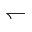Convert formula to latex. <formula><loc_0><loc_0><loc_500><loc_500>\leftharpoondown</formula> 